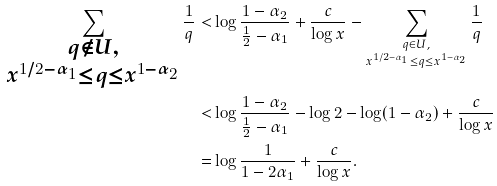Convert formula to latex. <formula><loc_0><loc_0><loc_500><loc_500>\sum _ { \substack { q \not \in U , \\ x ^ { 1 / 2 - \alpha _ { 1 } } \leq q \leq x ^ { 1 - \alpha _ { 2 } } } } \frac { 1 } { q } < & \log \frac { 1 - \alpha _ { 2 } } { \frac { 1 } { 2 } - \alpha _ { 1 } } + \frac { c } { \log x } - \sum _ { \substack { q \in U , \\ x ^ { 1 / 2 - \alpha _ { 1 } } \leq q \leq x ^ { 1 - \alpha _ { 2 } } } } \frac { 1 } { q } \\ < & \log \frac { 1 - \alpha _ { 2 } } { \frac { 1 } { 2 } - \alpha _ { 1 } } - \log 2 - \log ( 1 - \alpha _ { 2 } ) + \frac { c } { \log x } \\ = & \log \frac { 1 } { 1 - 2 \alpha _ { 1 } } + \frac { c } { \log x } .</formula> 